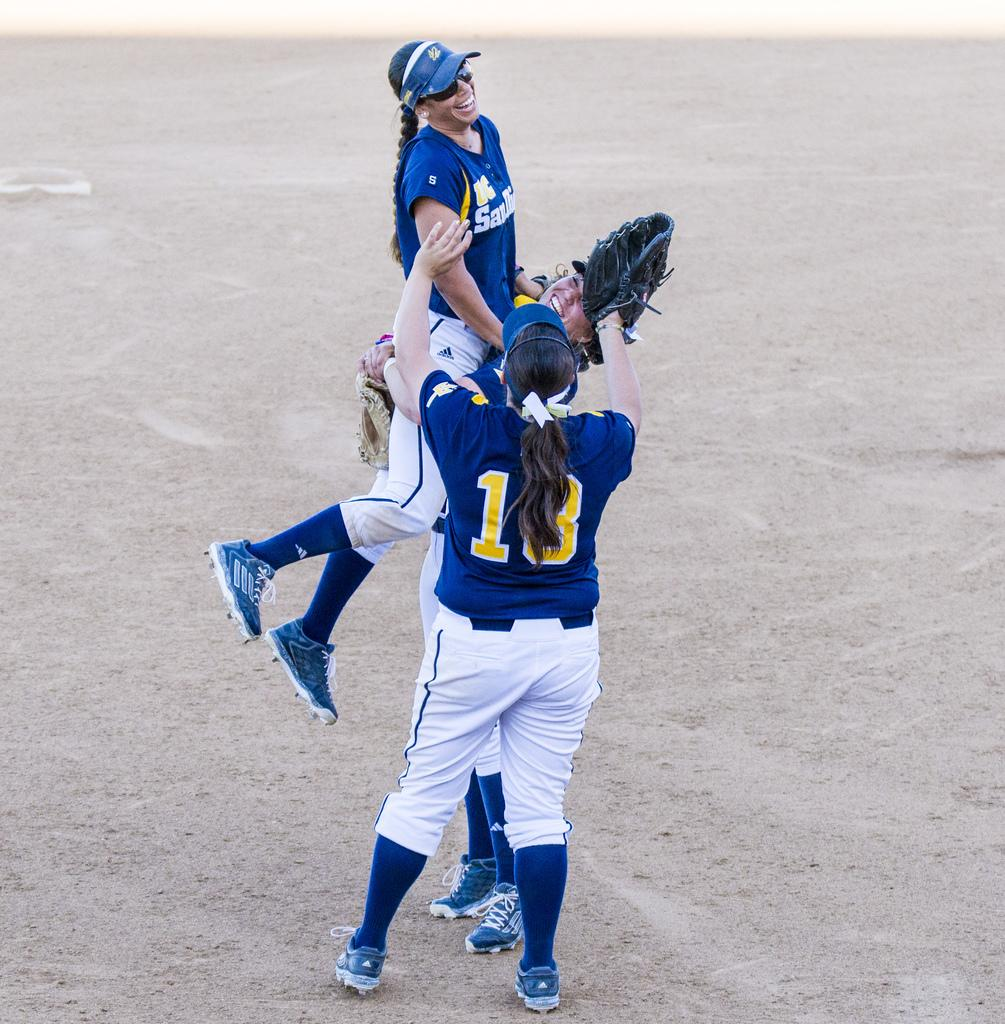Provide a one-sentence caption for the provided image. a base ball player with a SAN jersey jumping into the arms of other players. 